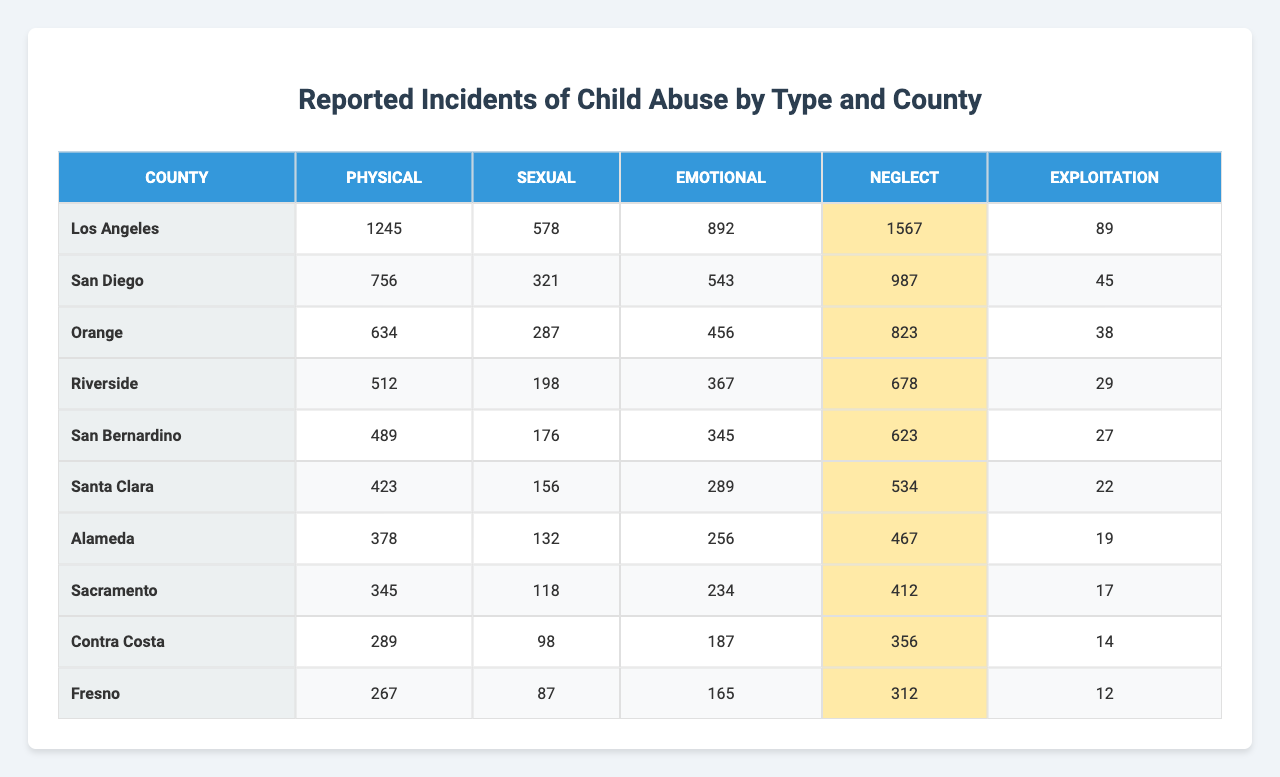What county has the highest reported incidents of physical abuse? Looking at the physical abuse column, Los Angeles has the highest reported incidents at 1245.
Answer: Los Angeles Which type of abuse has the least reported incidents in San Bernardino County? In San Bernardino County, the numbers for the abuse types are 489, 176, 345, 623, and 27. The lowest number is 27 for exploitation.
Answer: Exploitation What is the total number of reported incidents of emotional abuse across all counties? Adding the emotional abuse incidents: 892 + 543 + 456 + 367 + 345 + 289 + 256 + 234 + 187 + 165 = 3564.
Answer: 3564 Which county has the highest overall reported incidents of child abuse? To find the overall highest, we sum up incidents for each county: Los Angeles (3561), San Diego (2652), Orange (2238), Riverside (1876), San Bernardino (1660), Santa Clara (1420), Alameda (1250), Sacramento (1095), Contra Costa (1069), Fresno (965). Los Angeles has the highest at 3561.
Answer: Los Angeles Is there a county that has zero reported incidents for any type of abuse? By scanning all the values, every county has at least some reported incidents for each type of abuse as all numbers are greater than zero.
Answer: No What is the average number of reported incidents of neglect across all counties? Adding the neglect incidents: 1567 + 987 + 823 + 678 + 623 + 534 + 467 + 412 + 356 + 312 = 7564. Dividing by the number of counties (10), we get 7564 / 10 = 756.4.
Answer: 756.4 Which type of abuse is reported the least overall in Fresno County? The reported incidents for Fresno are 267 (Physical), 87 (Sexual), 165 (Emotional), 312 (Neglect), and 12 (Exploitation). The lowest is 12 for exploitation.
Answer: Exploitation How many more instances of sexual abuse were reported in Los Angeles compared to Santa Clara? Los Angeles has 578 instances and Santa Clara has 156. The difference is 578 - 156 = 422.
Answer: 422 Determine the highest reported incident type in San Diego County. The reported incidents for San Diego are 756 (Physical), 321 (Sexual), 543 (Emotional), 987 (Neglect), and 45 (Exploitation). The highest is 987 for neglect.
Answer: Neglect Which counties report more than 1000 incidents of physical abuse? The physical abuse incidents are as follows: Los Angeles (1245), San Diego (756), Orange (634), Riverside (512), San Bernardino (489), Santa Clara (423), Alameda (378), Sacramento (345), Contra Costa (289), and Fresno (267). The only county above 1000 is Los Angeles.
Answer: Los Angeles 